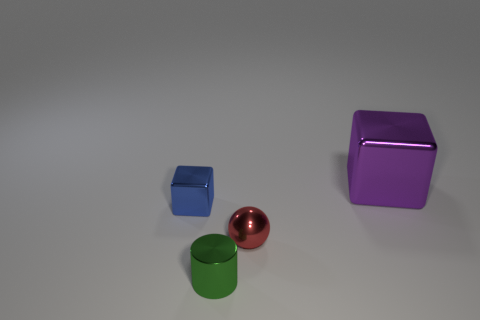Are there any big purple objects that have the same material as the small blue object?
Offer a very short reply. Yes. What is the color of the large metallic object?
Make the answer very short. Purple. What number of other large purple things have the same shape as the big object?
Keep it short and to the point. 0. How big is the metallic cube to the right of the metallic object that is in front of the red metallic ball?
Your answer should be very brief. Large. Is there anything else that is the same size as the purple metallic object?
Ensure brevity in your answer.  No. There is a small thing that is the same shape as the big purple metallic object; what is it made of?
Offer a very short reply. Metal. There is a thing on the right side of the red object; does it have the same shape as the tiny metallic thing behind the tiny red sphere?
Your answer should be compact. Yes. Are there more large brown metallic cylinders than purple objects?
Offer a terse response. No. What size is the green metallic cylinder?
Provide a succinct answer. Small. How many other things are there of the same color as the large block?
Make the answer very short. 0. 